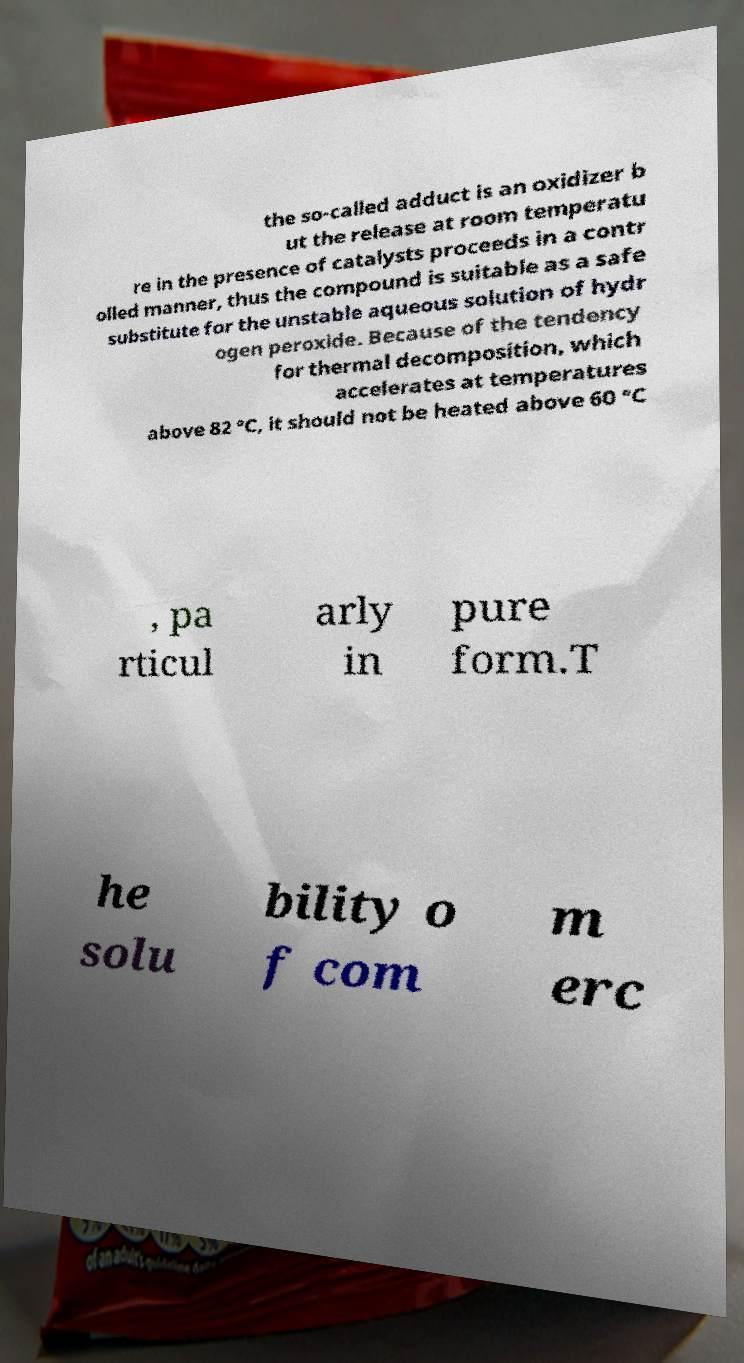Please read and relay the text visible in this image. What does it say? the so-called adduct is an oxidizer b ut the release at room temperatu re in the presence of catalysts proceeds in a contr olled manner, thus the compound is suitable as a safe substitute for the unstable aqueous solution of hydr ogen peroxide. Because of the tendency for thermal decomposition, which accelerates at temperatures above 82 °C, it should not be heated above 60 °C , pa rticul arly in pure form.T he solu bility o f com m erc 